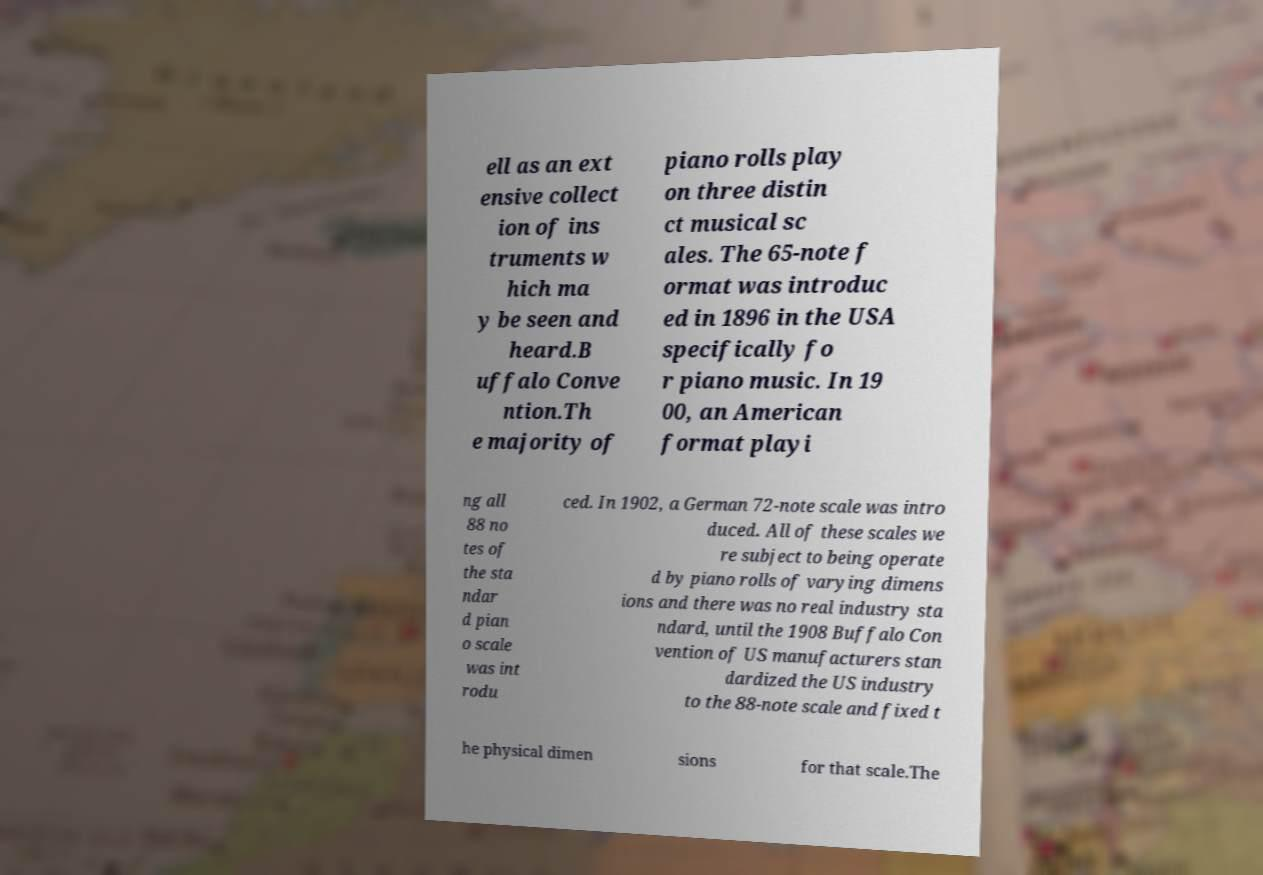There's text embedded in this image that I need extracted. Can you transcribe it verbatim? ell as an ext ensive collect ion of ins truments w hich ma y be seen and heard.B uffalo Conve ntion.Th e majority of piano rolls play on three distin ct musical sc ales. The 65-note f ormat was introduc ed in 1896 in the USA specifically fo r piano music. In 19 00, an American format playi ng all 88 no tes of the sta ndar d pian o scale was int rodu ced. In 1902, a German 72-note scale was intro duced. All of these scales we re subject to being operate d by piano rolls of varying dimens ions and there was no real industry sta ndard, until the 1908 Buffalo Con vention of US manufacturers stan dardized the US industry to the 88-note scale and fixed t he physical dimen sions for that scale.The 